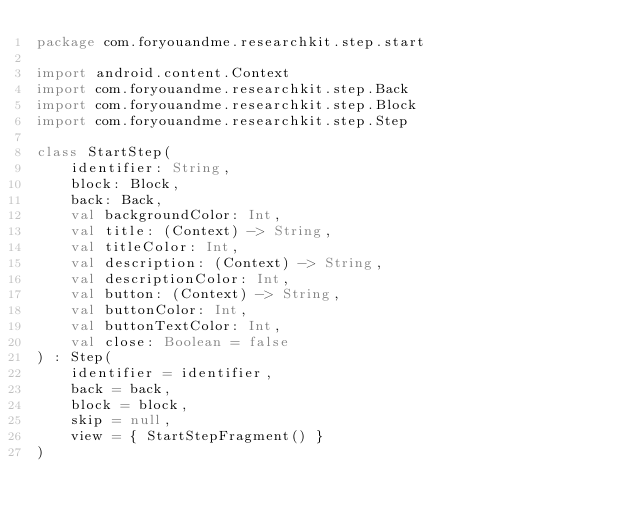Convert code to text. <code><loc_0><loc_0><loc_500><loc_500><_Kotlin_>package com.foryouandme.researchkit.step.start

import android.content.Context
import com.foryouandme.researchkit.step.Back
import com.foryouandme.researchkit.step.Block
import com.foryouandme.researchkit.step.Step

class StartStep(
    identifier: String,
    block: Block,
    back: Back,
    val backgroundColor: Int,
    val title: (Context) -> String,
    val titleColor: Int,
    val description: (Context) -> String,
    val descriptionColor: Int,
    val button: (Context) -> String,
    val buttonColor: Int,
    val buttonTextColor: Int,
    val close: Boolean = false
) : Step(
    identifier = identifier,
    back = back,
    block = block,
    skip = null,
    view = { StartStepFragment() }
)</code> 